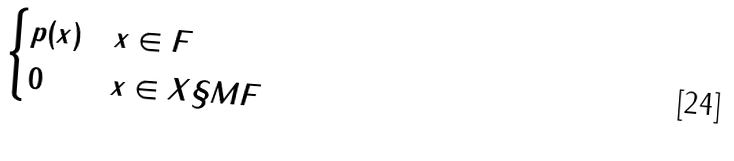Convert formula to latex. <formula><loc_0><loc_0><loc_500><loc_500>\begin{cases} p ( x ) & x \in F \\ 0 & x \in X \S M F \end{cases}</formula> 